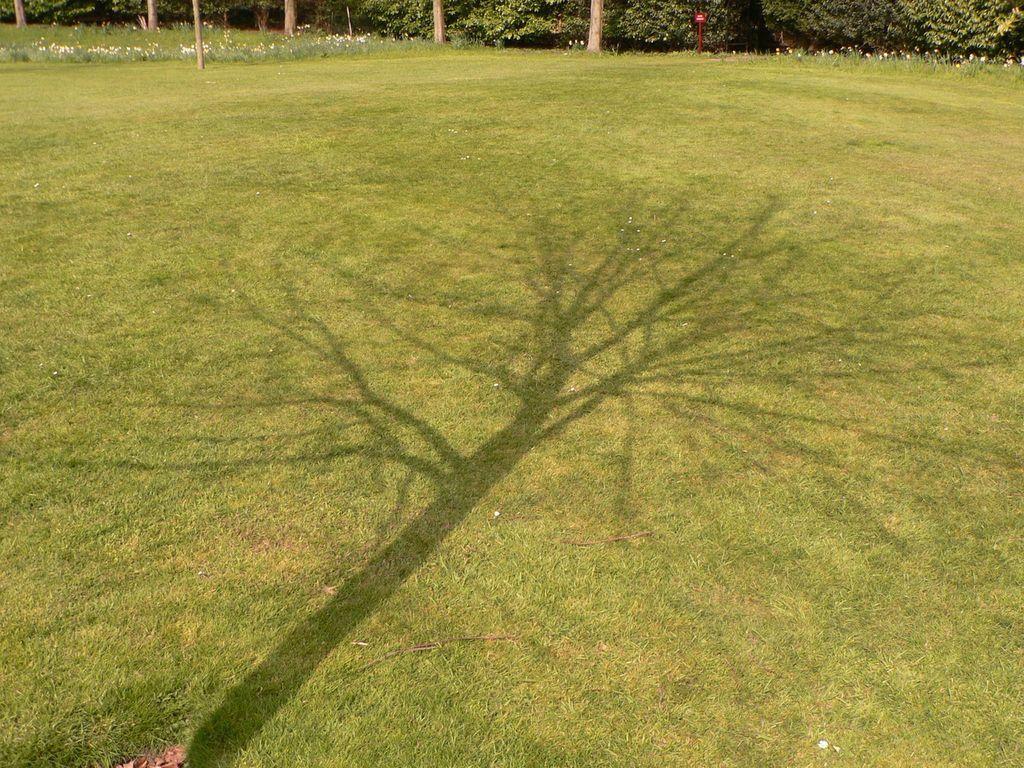Could you give a brief overview of what you see in this image? In the picture we can see a grass surface on it, we can see a tree shadow and in the background, we can see some plants and a tree branch. 